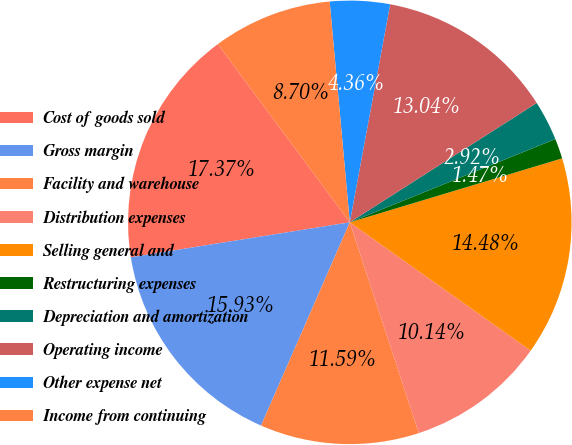Convert chart. <chart><loc_0><loc_0><loc_500><loc_500><pie_chart><fcel>Cost of goods sold<fcel>Gross margin<fcel>Facility and warehouse<fcel>Distribution expenses<fcel>Selling general and<fcel>Restructuring expenses<fcel>Depreciation and amortization<fcel>Operating income<fcel>Other expense net<fcel>Income from continuing<nl><fcel>17.37%<fcel>15.93%<fcel>11.59%<fcel>10.14%<fcel>14.48%<fcel>1.47%<fcel>2.92%<fcel>13.04%<fcel>4.36%<fcel>8.7%<nl></chart> 